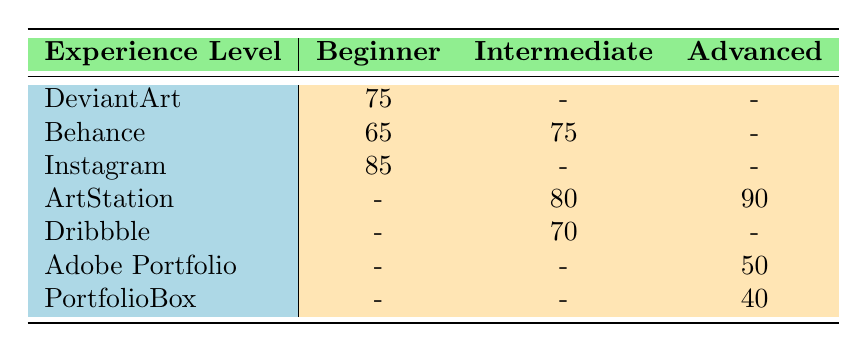What is the popularity of Instagram for beginner artists? According to the table, the popularity of Instagram under the 'Beginner' experience level is 85.
Answer: 85 Which platform has the highest popularity among advanced artists? For advanced artists, the platform with the highest popularity is ArtStation, with a value of 90.
Answer: 90 Is Behance more popular among intermediates than beginners? The popularity of Behance among intermediates is 75, while its popularity among beginners is 65. Since 75 is greater than 65, the statement is true.
Answer: Yes What is the difference in popularity between DeviantArt and Dribbble for intermediate artists? DeviantArt has no popularity score listed for intermediates (indicated by a dash), while Dribbble has a popularity of 70. This means DeviantArt's score is effectively 0, and the difference is 70 - 0 = 70.
Answer: 70 What is the average popularity score for platforms in the advanced category? The advanced platforms are Adobe Portfolio (50), ArtStation (90), and PortfolioBox (40). The sum is 50 + 90 + 40 = 180, and dividing by 3 gives an average of 60.
Answer: 60 